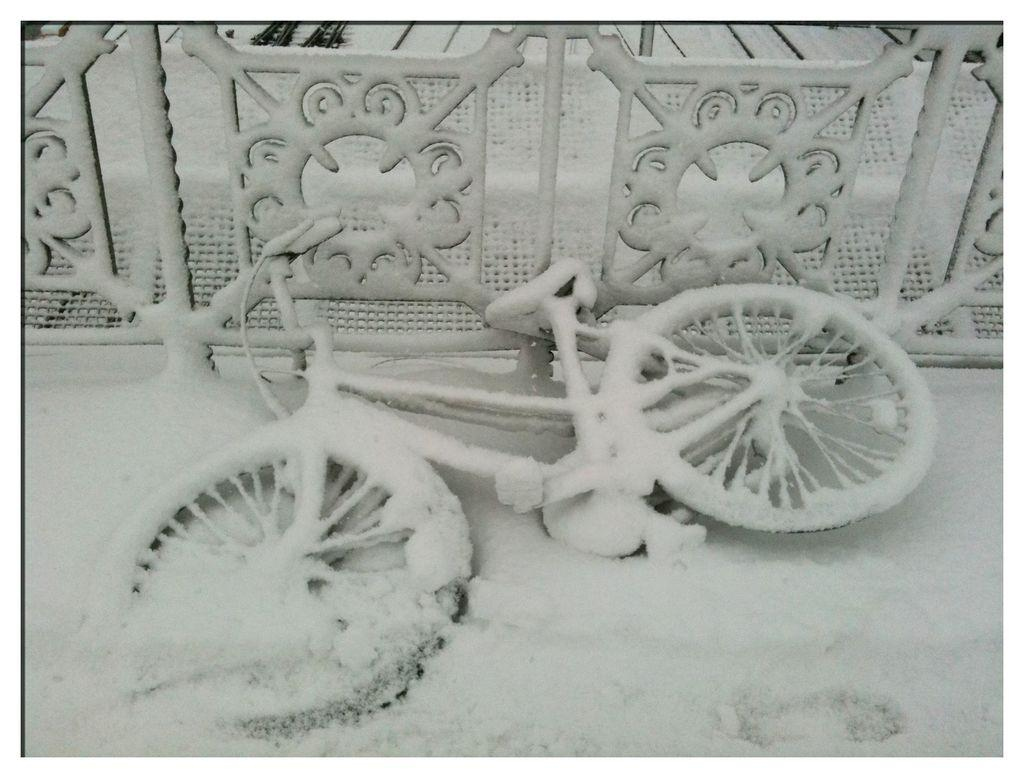What is the main object in the image? There is a bicycle in the image. What is the condition of the railing in the image? The railing is fully covered with snow in the image. Where is the pail located in the image? There is no pail present in the image. What type of body is visible in the image? There are no bodies present in the image; it only features a bicycle and a snow-covered railing. 